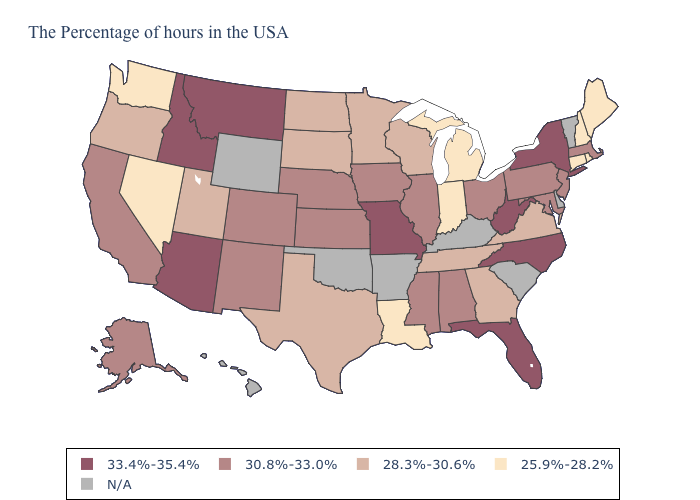Is the legend a continuous bar?
Concise answer only. No. Does the map have missing data?
Concise answer only. Yes. What is the value of Maryland?
Give a very brief answer. 30.8%-33.0%. What is the highest value in the USA?
Give a very brief answer. 33.4%-35.4%. Among the states that border Alabama , does Mississippi have the lowest value?
Give a very brief answer. No. Name the states that have a value in the range 25.9%-28.2%?
Concise answer only. Maine, Rhode Island, New Hampshire, Connecticut, Michigan, Indiana, Louisiana, Nevada, Washington. What is the lowest value in the South?
Be succinct. 25.9%-28.2%. What is the lowest value in the USA?
Keep it brief. 25.9%-28.2%. Among the states that border Michigan , which have the highest value?
Quick response, please. Ohio. What is the value of Wyoming?
Write a very short answer. N/A. Among the states that border Georgia , does Tennessee have the lowest value?
Short answer required. Yes. What is the lowest value in the Northeast?
Answer briefly. 25.9%-28.2%. Among the states that border Utah , does New Mexico have the lowest value?
Keep it brief. No. Which states have the lowest value in the USA?
Write a very short answer. Maine, Rhode Island, New Hampshire, Connecticut, Michigan, Indiana, Louisiana, Nevada, Washington. 